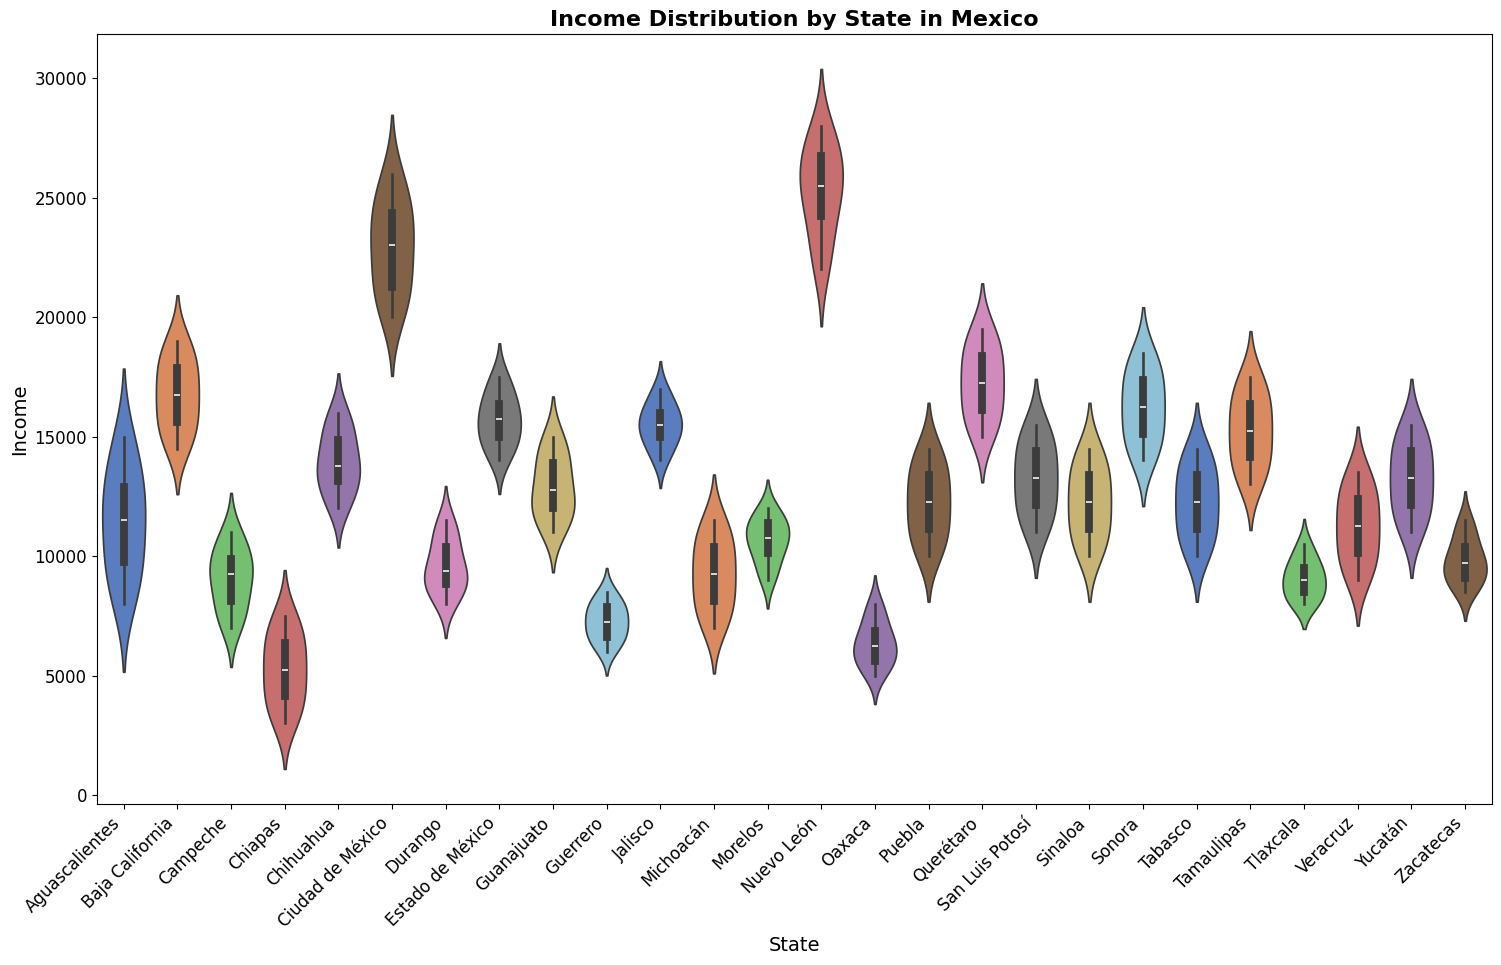Which state shows the highest variability in income distribution? By observing the width of the violin plots, the state with the widest plot represents the highest variability. Ciudad de México has the largest spread in the income distribution, hence the highest variability.
Answer: Ciudad de México Which states have the smallest range in income distribution? To determine the states with the smallest range, look for the states with the narrowest violin plots. Chiapas and Tlaxcala have the smallest width, indicating a smaller range in income distribution.
Answer: Chiapas, Tlaxcala What is the median income in Nuevo León? The median is represented by the white dot within the violin plot. For Nuevo León, this dot is located around 26000.
Answer: 26000 Which state has the highest median income? Comparing the white dots across all states, Ciudad de México and Nuevo León have the highest medians. Out of these, Ciudad de México has a slightly higher median.
Answer: Ciudad de México Which state has the lowest median income? By comparing the position of the white dots, Chiapas has the lowest median income, positioned around 5000.
Answer: Chiapas Between Jalisco and Sonora, which state has a higher median income? By locating the white dots for Jalisco and Sonora, it is clear that Sonora's median income (around 16000) is higher than Jalisco's (around 15500).
Answer: Sonora On average, which has higher incomes: Aguascalientes or Guanajuato? To determine the average, compare the overall height of the violin plots. Both seem to have clusters around mid-values, but Guanajuato’s plot is slightly higher, indicating a higher average income.
Answer: Guanajuato Which state has a larger income distribution, Puebla or Tabasco? Observing the range or spread of the violin plots, both Puebla and Tabasco have similarly wide plots. However, Puebla’s plot covers a slightly broader range.
Answer: Puebla What is the interquartile range (IQR) for Querétaro? The IQR is the range where the central 50% of incomes lie, represented by the thick part of the violin plot. For Querétaro, the IQR is between 15500 and 18000, thus the IQR is approximately 2500.
Answer: 2500 Compare the income distribution of Chihuaha and Durango. Which has a wider spread? By comparing the width of the violin plots, Chihuahua has a slightly wider spread in its income distribution compared to Durango.
Answer: Chihuahua 